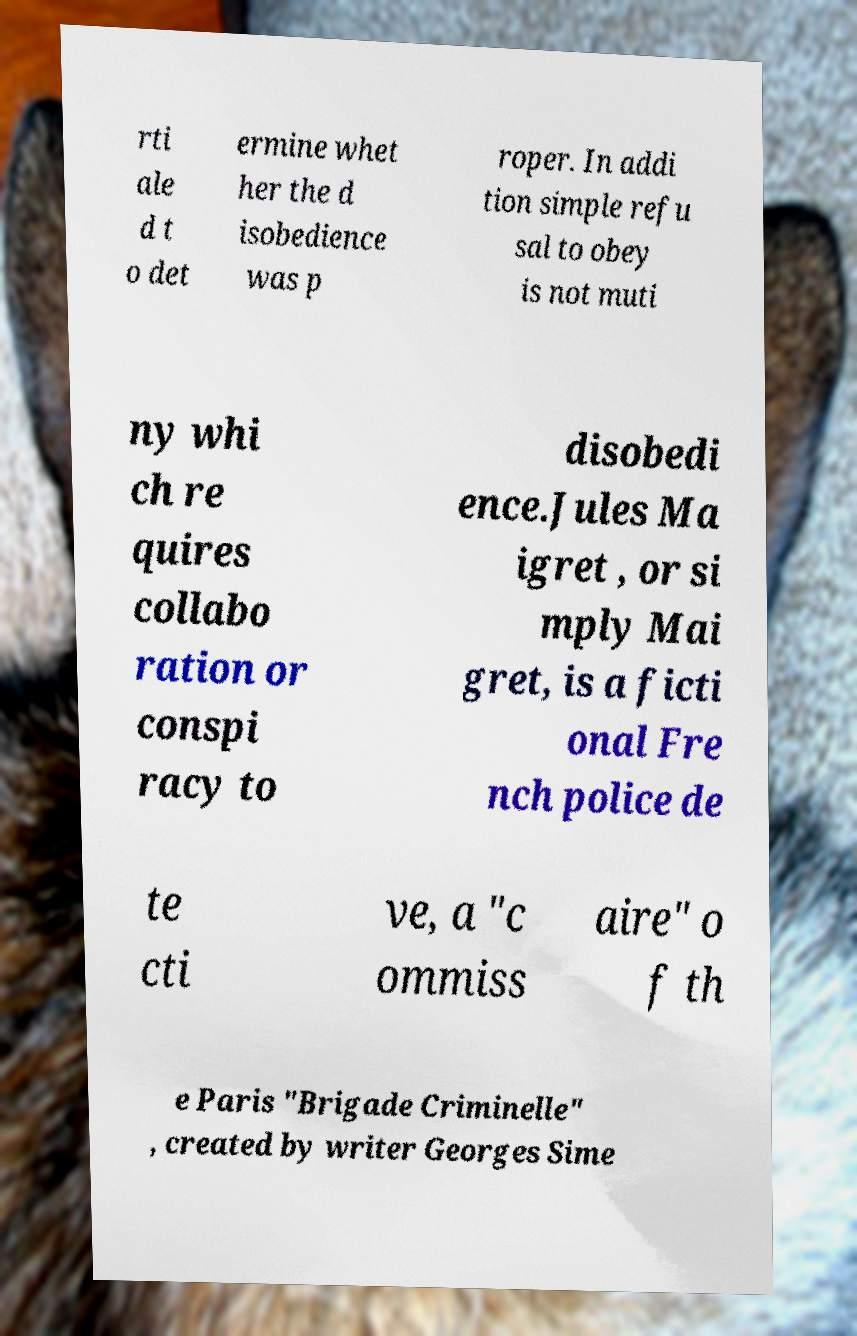Could you extract and type out the text from this image? rti ale d t o det ermine whet her the d isobedience was p roper. In addi tion simple refu sal to obey is not muti ny whi ch re quires collabo ration or conspi racy to disobedi ence.Jules Ma igret , or si mply Mai gret, is a ficti onal Fre nch police de te cti ve, a "c ommiss aire" o f th e Paris "Brigade Criminelle" , created by writer Georges Sime 